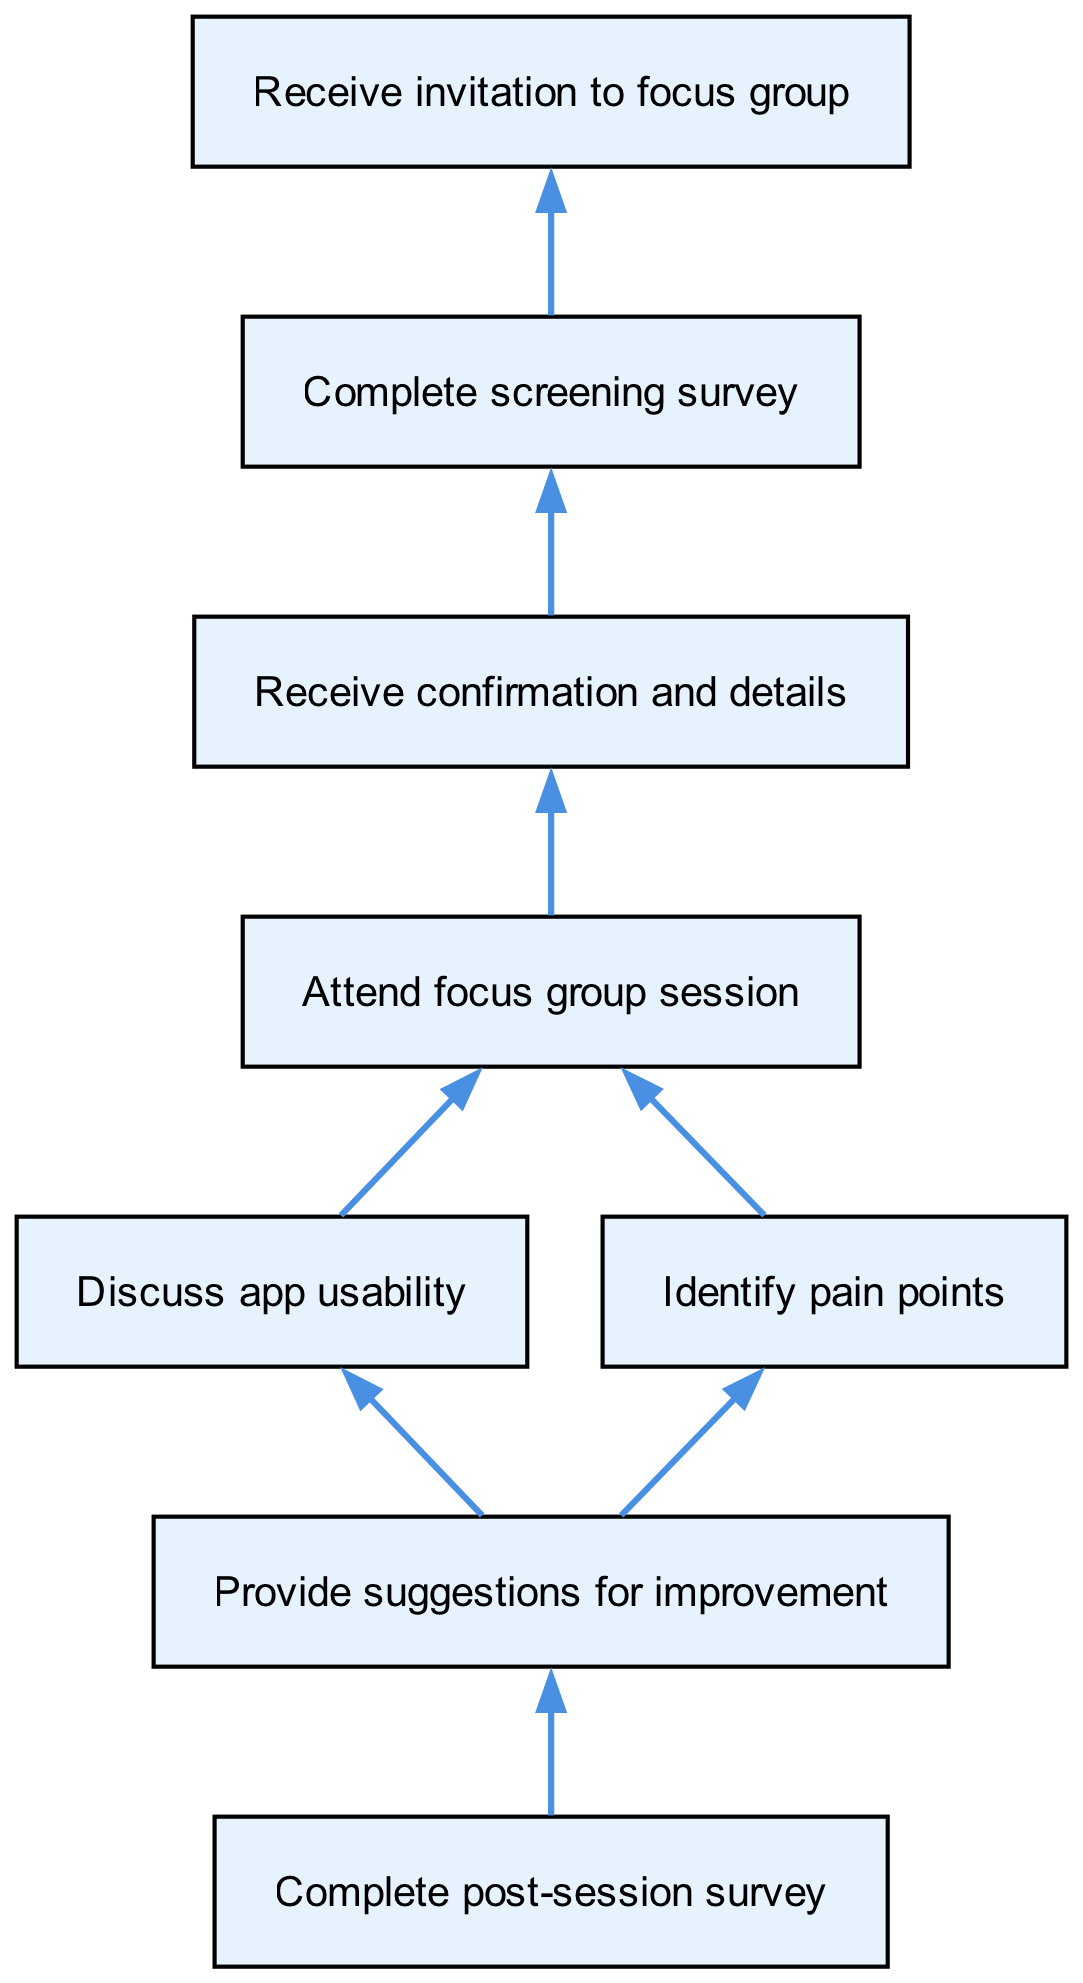What is the first step in the focus group process? The diagram begins with the node "Receive invitation to focus group," which clearly indicates that this is the first step before any other actions take place.
Answer: Receive invitation to focus group How many connections are there from the "Attend focus group session" node? The "Attend focus group session" node connects to two different nodes: "Discuss app usability" and "Identify pain points." This indicates that there are two connections leading from this step.
Answer: 2 What is the last action participants take after the focus group session? According to the diagram, the final node is "Complete post-session survey," and this is the last action participants are required to complete after the focus group session ends.
Answer: Complete post-session survey Which two nodes follow the "Attend focus group session"? From the "Attend focus group session" node, the next steps are "Discuss app usability" and "Identify pain points," both of which occur immediately after the session.
Answer: Discuss app usability, Identify pain points Which step directly follows the "Complete screening survey"? The connection leads directly to the "Receive confirmation and details" node, indicating that once the screening survey is completed, the next step is to receive confirmation and more details about the focus group.
Answer: Receive confirmation and details What is the main focus of the discussions during the focus group session? The diagram illustrates that during the session, participants will primarily focus on two aspects: "Discuss app usability" and "Identify pain points," both serving as key discussion topics during the session.
Answer: Discuss app usability, Identify pain points What type of feedback is provided at the end of the focus group process? At the end of the process, participants provide "suggestions for improvement," as shown in the diagram, indicating the primary feedback they are expected to give after identifying potential issues.
Answer: Suggestions for improvement How many elements are there in the focus group process? The diagram lists a total of eight distinct elements or steps that comprise the complete process of participating in the focus group from start to finish.
Answer: 8 